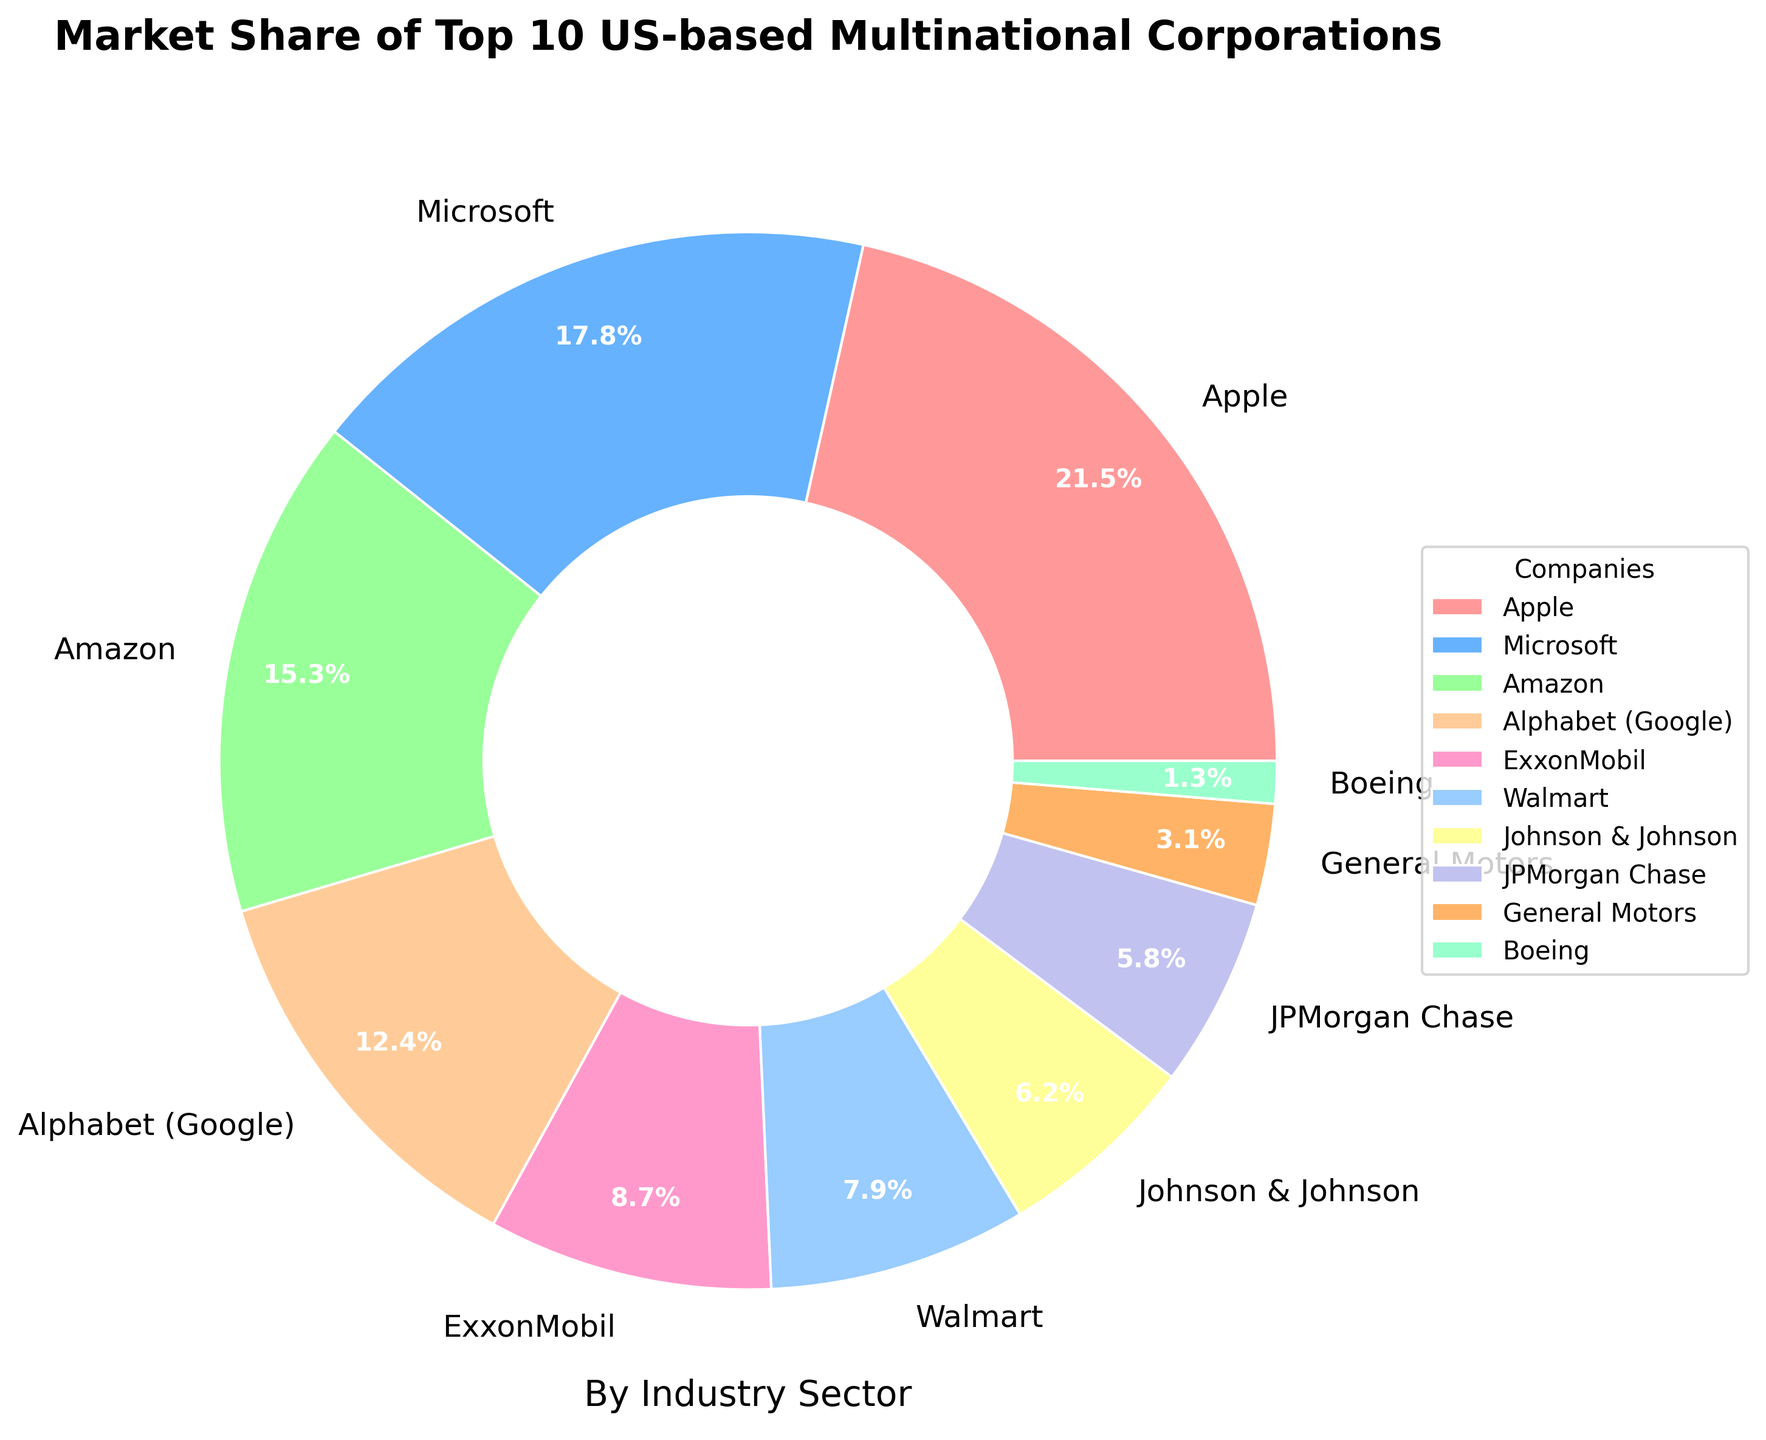What is the market share of Apple? The pie chart shows the market shares of different companies, and specifically, Apple's market share is labeled.
Answer: 21.5% Which sector has the highest market share, and which company represents it? By visually inspecting the largest segment of the pie chart, it is clear that the sector with the highest market share is Technology, represented by Apple.
Answer: Technology, Apple What is the combined market share of companies in the Technology sector? Summing up the market shares of Apple, Microsoft, Amazon, and Alphabet (Google), we get 21.5% + 17.8% + 15.3% + 12.4%.
Answer: 67% How does Walmart's market share compare to ExxonMobil's? Walmart's market share is 7.9% and ExxonMobil's is 8.7%; comparing these shows that ExxonMobil has a higher market share.
Answer: ExxonMobil has a higher market share than Walmart Which company has the smallest market share and what sector does it belong to? The smallest segment of the pie chart represents Boeing with a market share of 1.3%, and it belongs to the Aerospace sector.
Answer: Boeing, Aerospace What is the difference in market share between Amazon and Johnson & Johnson? Amazon's market share is 15.3% while Johnson & Johnson's is 6.2%; the difference is obtained by subtracting the two.
Answer: 9.1% Considering the Finance and Automotive sectors, what is their total market share? Adding the market shares of JPMorgan Chase (5.8%) and General Motors (3.1%), we get the total market share for Finance and Automotive sectors.
Answer: 8.9% What's the average market share of companies in non-Technology sectors? Summing the market shares of ExxonMobil, Walmart, Johnson & Johnson, JPMorgan Chase, General Motors, and Boeing, then dividing by the number of these companies (6), we get the average.
Answer: 5.5% How many companies have a market share greater than 10%? By examining the pie chart, we identify Apple, Microsoft, Amazon, and Alphabet (Google) as having market shares greater than 10%. Counting these companies gives us the number.
Answer: 4 What is the visual color representation for the company in the aerospace sector? By visually inspecting the color associated with Boeing in the pie chart legend, we identify the color as light green.
Answer: light green 